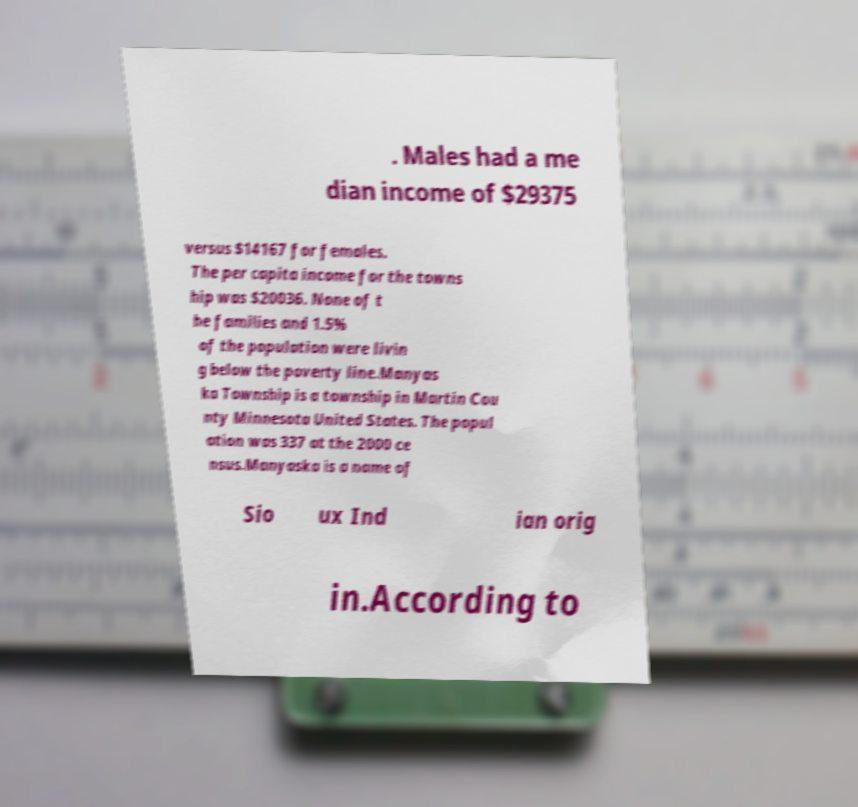Please identify and transcribe the text found in this image. . Males had a me dian income of $29375 versus $14167 for females. The per capita income for the towns hip was $20036. None of t he families and 1.5% of the population were livin g below the poverty line.Manyas ka Township is a township in Martin Cou nty Minnesota United States. The popul ation was 337 at the 2000 ce nsus.Manyaska is a name of Sio ux Ind ian orig in.According to 